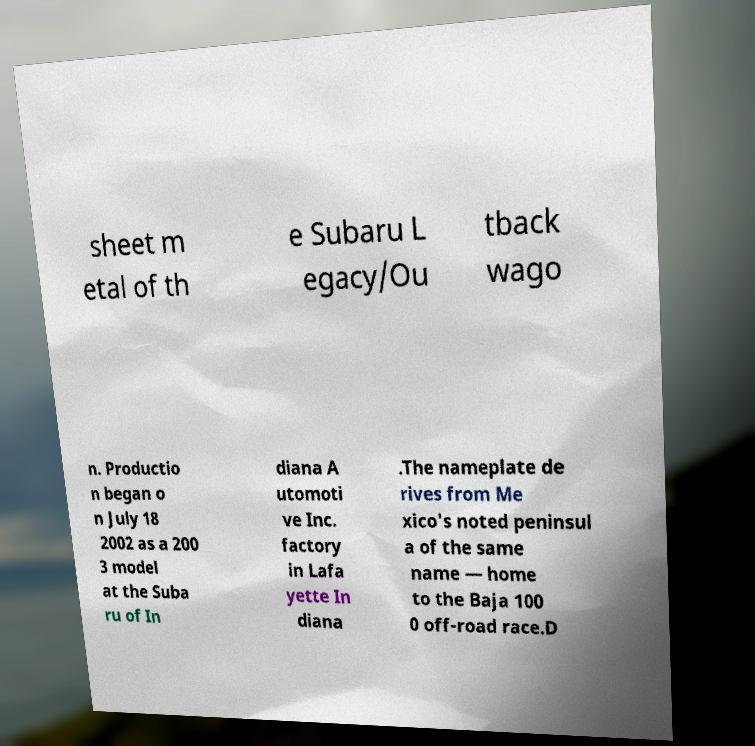Can you read and provide the text displayed in the image?This photo seems to have some interesting text. Can you extract and type it out for me? sheet m etal of th e Subaru L egacy/Ou tback wago n. Productio n began o n July 18 2002 as a 200 3 model at the Suba ru of In diana A utomoti ve Inc. factory in Lafa yette In diana .The nameplate de rives from Me xico's noted peninsul a of the same name — home to the Baja 100 0 off-road race.D 